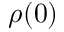<formula> <loc_0><loc_0><loc_500><loc_500>\rho ( 0 )</formula> 